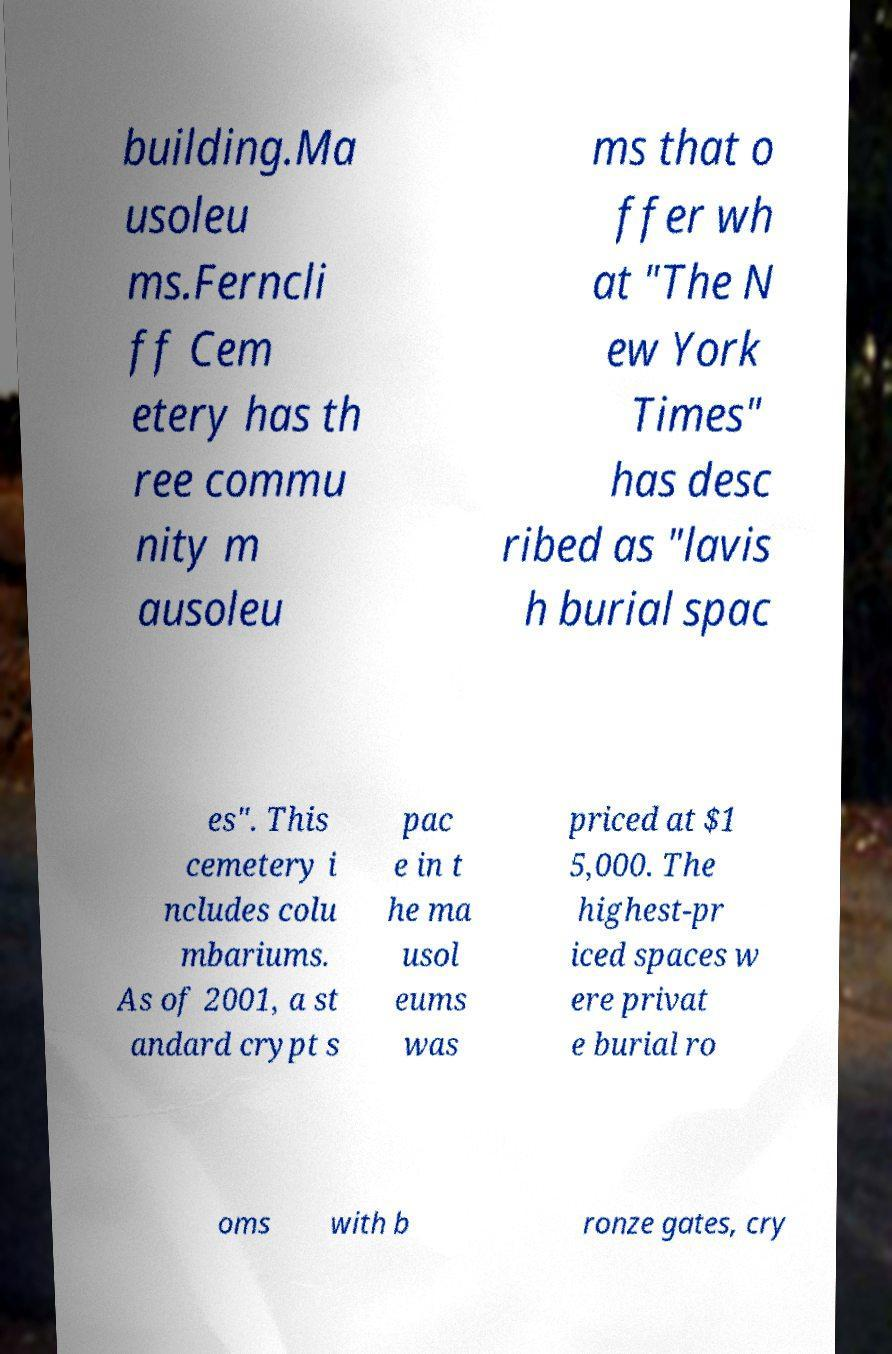Could you extract and type out the text from this image? building.Ma usoleu ms.Ferncli ff Cem etery has th ree commu nity m ausoleu ms that o ffer wh at "The N ew York Times" has desc ribed as "lavis h burial spac es". This cemetery i ncludes colu mbariums. As of 2001, a st andard crypt s pac e in t he ma usol eums was priced at $1 5,000. The highest-pr iced spaces w ere privat e burial ro oms with b ronze gates, cry 